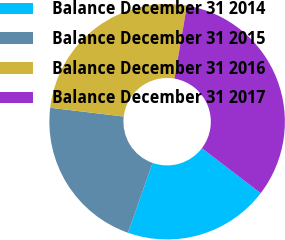<chart> <loc_0><loc_0><loc_500><loc_500><pie_chart><fcel>Balance December 31 2014<fcel>Balance December 31 2015<fcel>Balance December 31 2016<fcel>Balance December 31 2017<nl><fcel>20.01%<fcel>21.5%<fcel>25.8%<fcel>32.69%<nl></chart> 